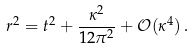Convert formula to latex. <formula><loc_0><loc_0><loc_500><loc_500>r ^ { 2 } = t ^ { 2 } + \frac { \kappa ^ { 2 } } { 1 2 \pi ^ { 2 } } + \mathcal { O } ( \kappa ^ { 4 } ) \, .</formula> 